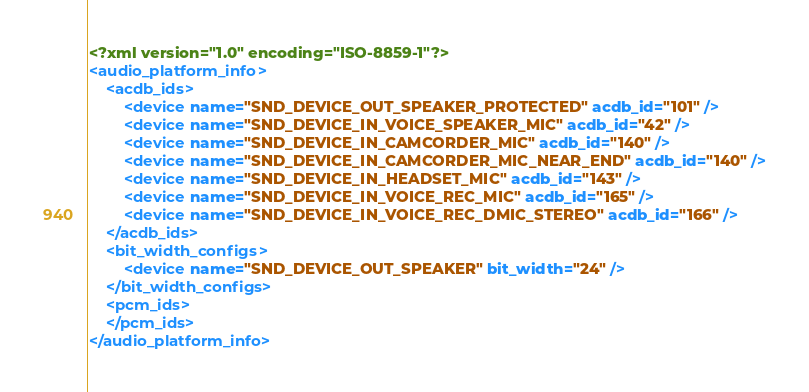<code> <loc_0><loc_0><loc_500><loc_500><_XML_><?xml version="1.0" encoding="ISO-8859-1"?>
<audio_platform_info>
    <acdb_ids>
        <device name="SND_DEVICE_OUT_SPEAKER_PROTECTED" acdb_id="101" />
        <device name="SND_DEVICE_IN_VOICE_SPEAKER_MIC" acdb_id="42" />
        <device name="SND_DEVICE_IN_CAMCORDER_MIC" acdb_id="140" />
        <device name="SND_DEVICE_IN_CAMCORDER_MIC_NEAR_END" acdb_id="140" />
        <device name="SND_DEVICE_IN_HEADSET_MIC" acdb_id="143" />
        <device name="SND_DEVICE_IN_VOICE_REC_MIC" acdb_id="165" />
        <device name="SND_DEVICE_IN_VOICE_REC_DMIC_STEREO" acdb_id="166" />
    </acdb_ids>
    <bit_width_configs>
        <device name="SND_DEVICE_OUT_SPEAKER" bit_width="24" />
    </bit_width_configs>
    <pcm_ids>
    </pcm_ids>
</audio_platform_info>
</code> 